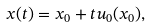<formula> <loc_0><loc_0><loc_500><loc_500>x ( t ) = x _ { 0 } + t u _ { 0 } ( x _ { 0 } ) ,</formula> 